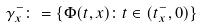<formula> <loc_0><loc_0><loc_500><loc_500>\gamma _ { x } ^ { - } \colon = \{ \Phi ( t , x ) \colon t \in ( t _ { x } ^ { - } , 0 ) \}</formula> 